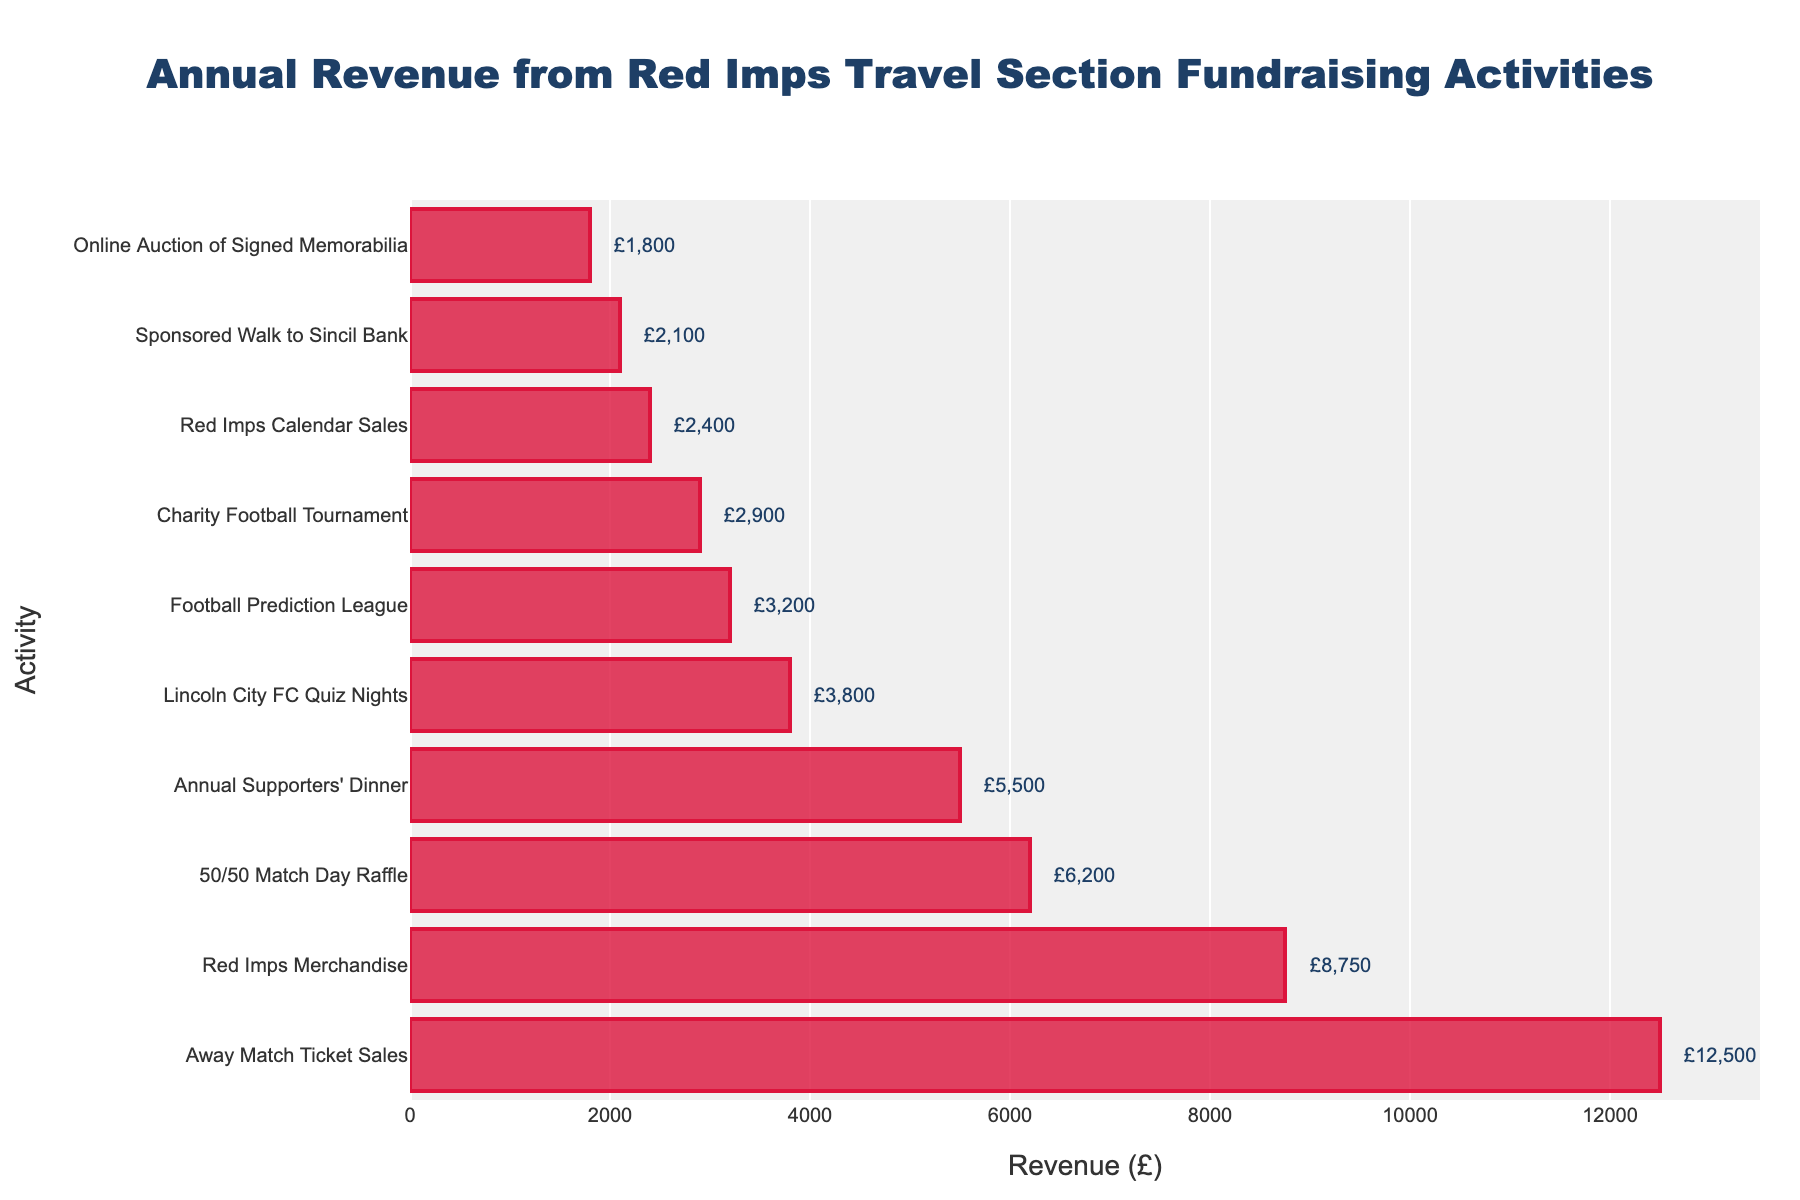What activity generated the highest revenue? The longest bar in the bar chart corresponds to the "Away Match Ticket Sales" activity. From the annotations, we can see that its revenue is £12,500.
Answer: Away Match Ticket Sales Which activity generated more revenue: "Red Imps Merchandise" or "50/50 Match Day Raffle"? The bar representing "Red Imps Merchandise" is longer than the one representing "50/50 Match Day Raffle". The annotations show that "Red Imps Merchandise" generated £8,750, while "50/50 Match Day Raffle" generated £6,200.
Answer: Red Imps Merchandise What is the difference in revenue between the "Football Prediction League" and "Charity Football Tournament"? The bar for "Football Prediction League" is longer than that for "Charity Football Tournament". "Football Prediction League" generated £3,200 and "Charity Football Tournament" generated £2,900. The difference is £3,200 - £2,900 = £300.
Answer: £300 What is the total revenue generated by the top three activities? The top three activities are "Away Match Ticket Sales" (£12,500), "Red Imps Merchandise" (£8,750), and "50/50 Match Day Raffle" (£6,200). The total revenue is £12,500 + £8,750 + £6,200 = £27,450.
Answer: £27,450 Which activity generated the least revenue? The shortest bar in the bar chart corresponds to the "Online Auction of Signed Memorabilia" activity. From the annotations, we see that its revenue is £1,800.
Answer: Online Auction of Signed Memorabilia How much more revenue did "Annual Supporters' Dinner" generate compared to "Lincoln City FC Quiz Nights"? The bar for "Annual Supporters' Dinner" is longer than the one for "Lincoln City FC Quiz Nights". "Annual Supporters' Dinner" generated £5,500 and "Lincoln City FC Quiz Nights" generated £3,800. The difference is £5,500 - £3,800 = £1,700.
Answer: £1,700 What is the average revenue generated by all activities combined? First, sum up all the revenues: £12,500 + £8,750 + £6,200 + £5,500 + £3,800 + £3,200 + £2,900 + £2,400 + £2,100 + £1,800 = £49,150. There are 10 activities. The average revenue is £49,150 / 10 = £4,915.
Answer: £4,915 Which two activities have the closest revenues and what is the difference between them? The closest revenues are for "Charity Football Tournament" (£2,900) and "Red Imps Calendar Sales" (£2,400). The difference is £2,900 - £2,400 = £500.
Answer: Charity Football Tournament and Red Imps Calendar Sales, £500 